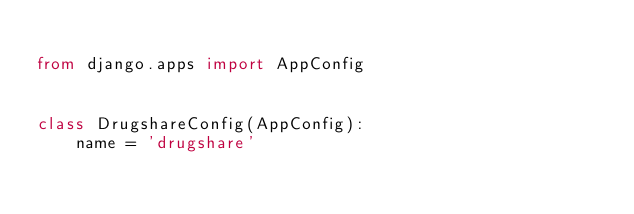Convert code to text. <code><loc_0><loc_0><loc_500><loc_500><_Python_>
from django.apps import AppConfig


class DrugshareConfig(AppConfig):
    name = 'drugshare'
</code> 